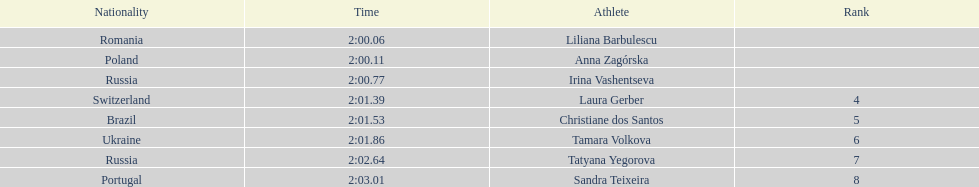What is the name of the highest-ranking finalist in this semifinals round? Liliana Barbulescu. 